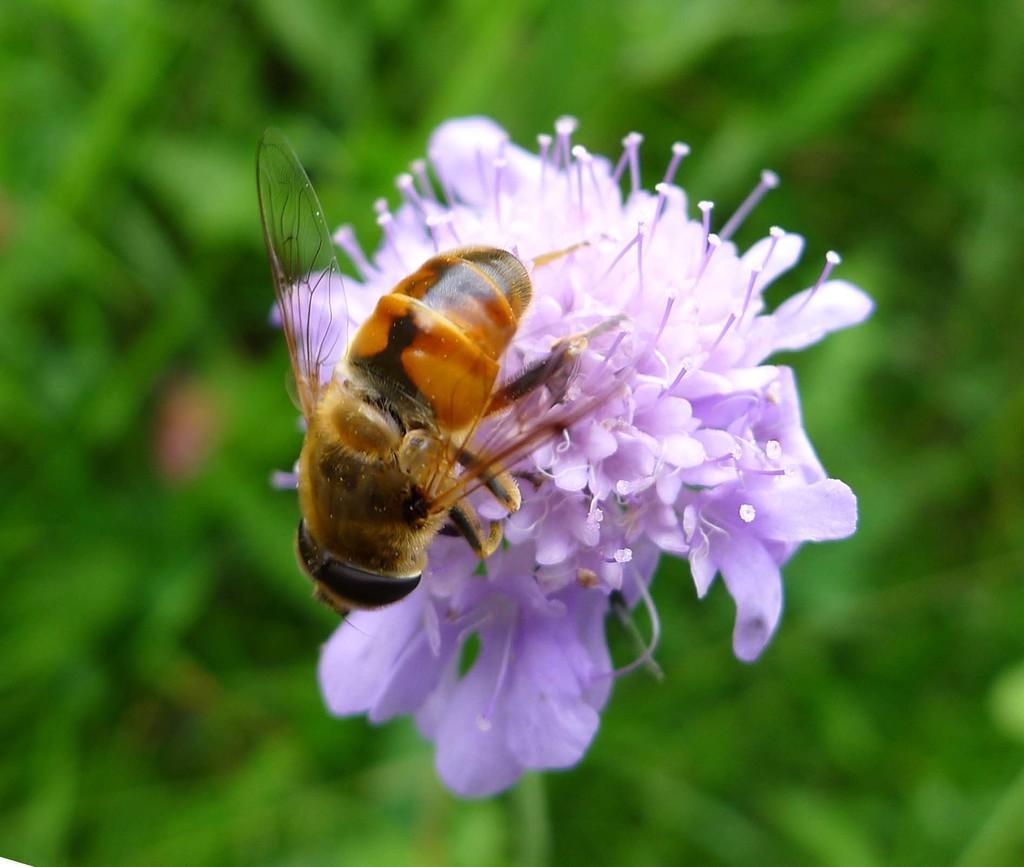Could you give a brief overview of what you see in this image? In the middle of this image, there is an insect standing on the surface light violet color flowers. And the background is blurred. 